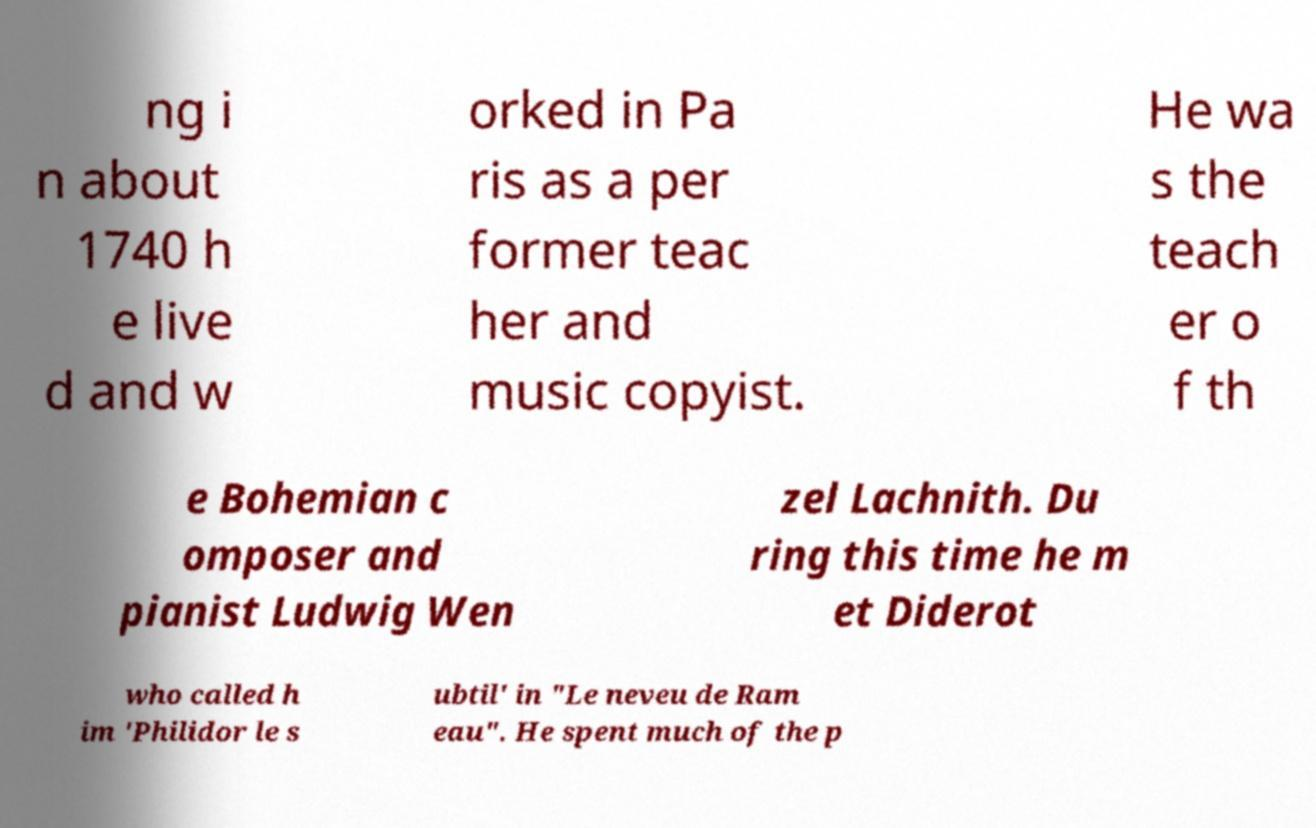For documentation purposes, I need the text within this image transcribed. Could you provide that? ng i n about 1740 h e live d and w orked in Pa ris as a per former teac her and music copyist. He wa s the teach er o f th e Bohemian c omposer and pianist Ludwig Wen zel Lachnith. Du ring this time he m et Diderot who called h im 'Philidor le s ubtil' in "Le neveu de Ram eau". He spent much of the p 